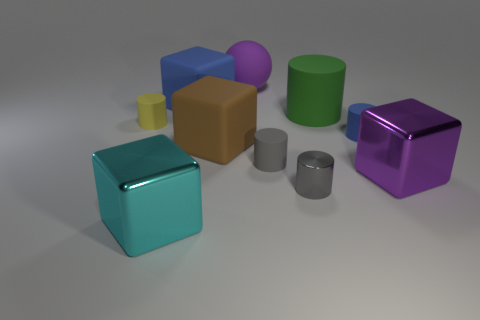Subtract all gray cylinders. How many were subtracted if there are1gray cylinders left? 1 Subtract all blocks. How many objects are left? 6 Subtract 5 cylinders. How many cylinders are left? 0 Subtract all cyan cylinders. Subtract all brown blocks. How many cylinders are left? 5 Subtract all gray spheres. How many gray cylinders are left? 2 Subtract all blue matte cylinders. Subtract all big brown rubber cubes. How many objects are left? 8 Add 4 big brown cubes. How many big brown cubes are left? 5 Add 2 yellow blocks. How many yellow blocks exist? 2 Subtract all yellow cylinders. How many cylinders are left? 4 Subtract all small blue cylinders. How many cylinders are left? 4 